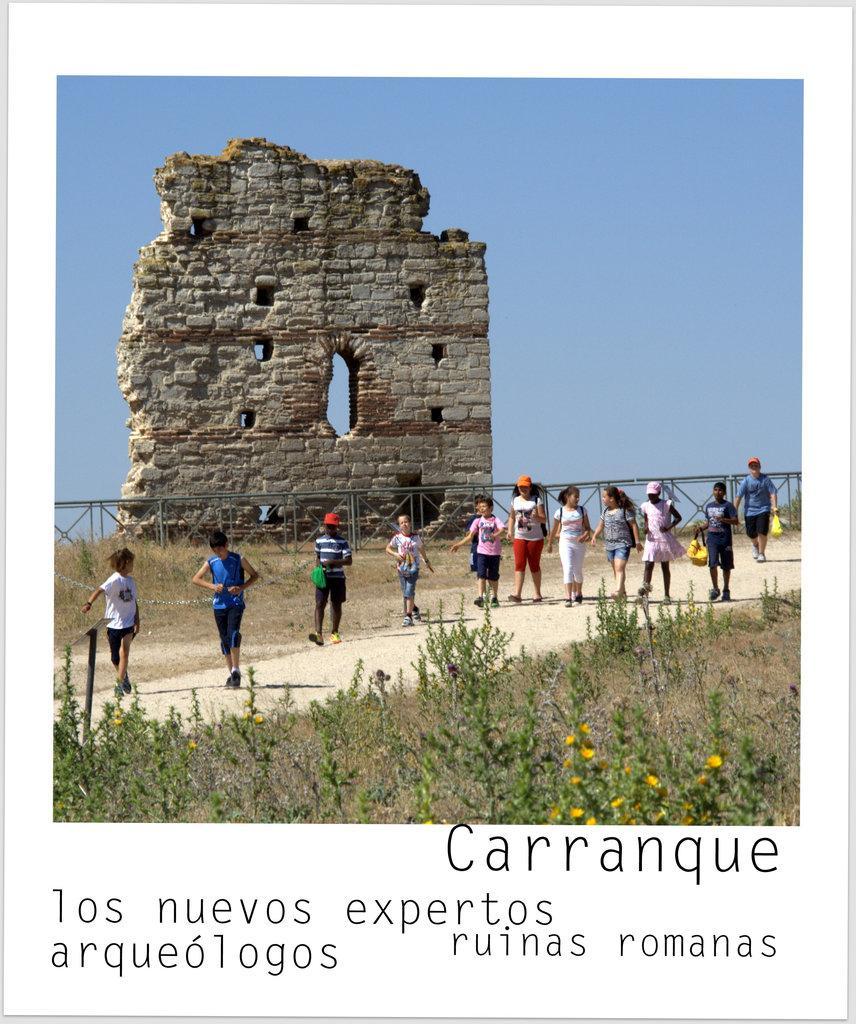Describe this image in one or two sentences. This is a poster in this image in the center there is a wall and railing and some persons are walking, and at the bottom there are some plants and grass and at the bottom of the image there is some text. 